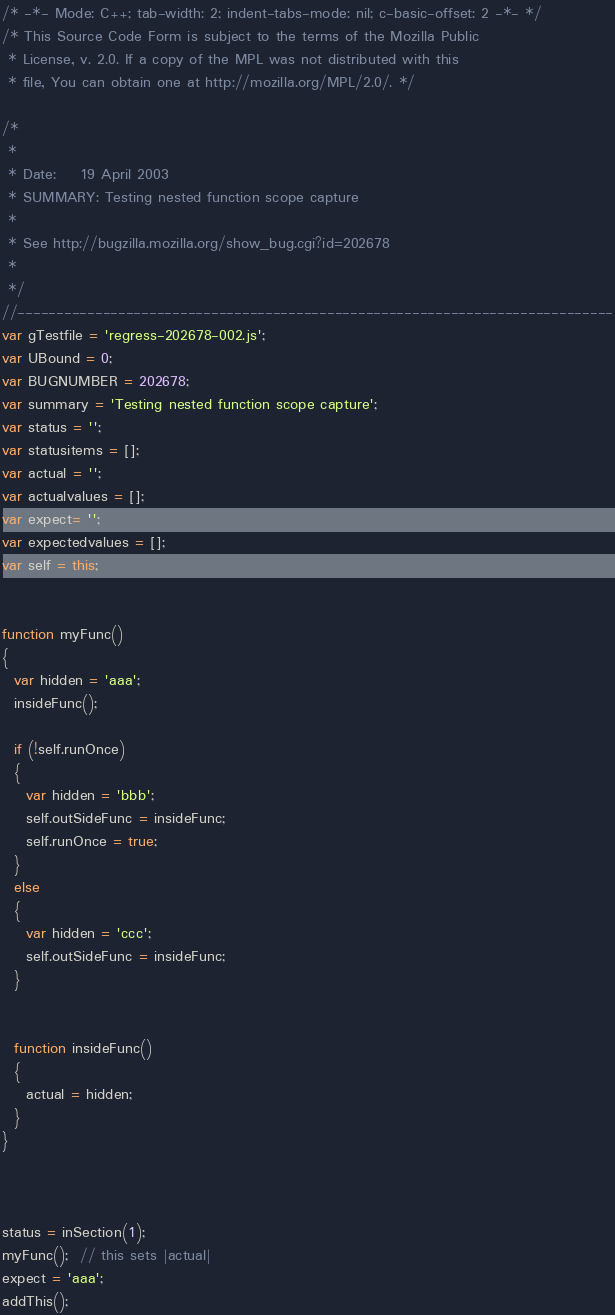Convert code to text. <code><loc_0><loc_0><loc_500><loc_500><_JavaScript_>/* -*- Mode: C++; tab-width: 2; indent-tabs-mode: nil; c-basic-offset: 2 -*- */
/* This Source Code Form is subject to the terms of the Mozilla Public
 * License, v. 2.0. If a copy of the MPL was not distributed with this
 * file, You can obtain one at http://mozilla.org/MPL/2.0/. */

/*
 *
 * Date:    19 April 2003
 * SUMMARY: Testing nested function scope capture
 *
 * See http://bugzilla.mozilla.org/show_bug.cgi?id=202678
 *
 */
//-----------------------------------------------------------------------------
var gTestfile = 'regress-202678-002.js';
var UBound = 0;
var BUGNUMBER = 202678;
var summary = 'Testing nested function scope capture';
var status = '';
var statusitems = [];
var actual = '';
var actualvalues = [];
var expect= '';
var expectedvalues = [];
var self = this;


function myFunc()
{
  var hidden = 'aaa';
  insideFunc();

  if (!self.runOnce)
  {
    var hidden = 'bbb';
    self.outSideFunc = insideFunc;
    self.runOnce = true;
  }
  else
  {
    var hidden = 'ccc';
    self.outSideFunc = insideFunc;
  }


  function insideFunc()
  {
    actual = hidden;
  }
}



status = inSection(1);
myFunc();  // this sets |actual|
expect = 'aaa';
addThis();
</code> 